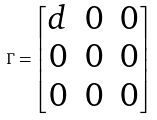<formula> <loc_0><loc_0><loc_500><loc_500>\Gamma = \begin{bmatrix} d & 0 & 0 \\ 0 & 0 & 0 \\ 0 & 0 & 0 \end{bmatrix}</formula> 